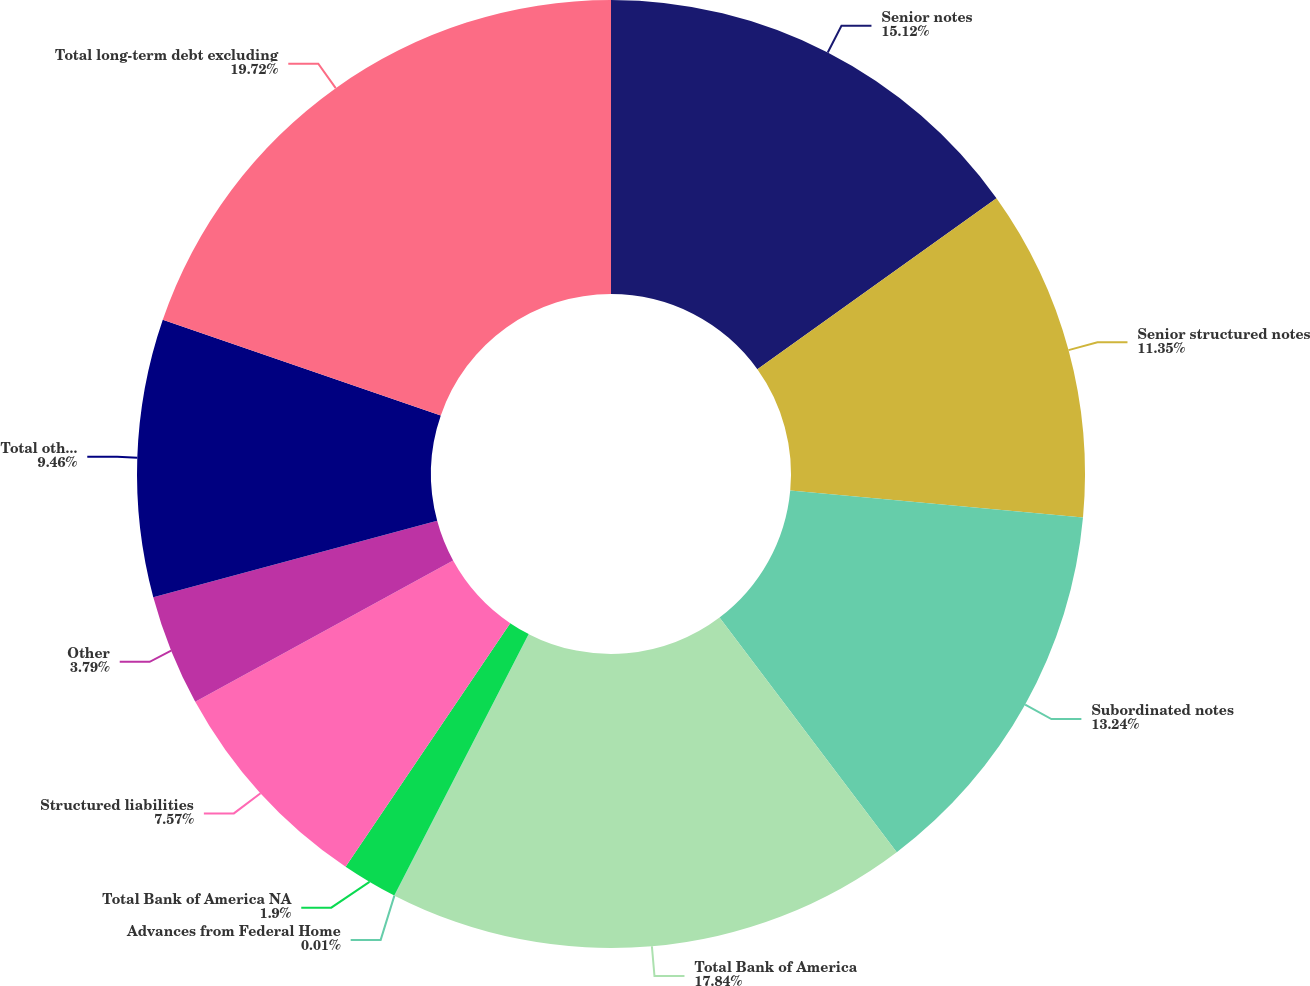Convert chart to OTSL. <chart><loc_0><loc_0><loc_500><loc_500><pie_chart><fcel>Senior notes<fcel>Senior structured notes<fcel>Subordinated notes<fcel>Total Bank of America<fcel>Advances from Federal Home<fcel>Total Bank of America NA<fcel>Structured liabilities<fcel>Other<fcel>Total other debt<fcel>Total long-term debt excluding<nl><fcel>15.12%<fcel>11.35%<fcel>13.24%<fcel>17.85%<fcel>0.01%<fcel>1.9%<fcel>7.57%<fcel>3.79%<fcel>9.46%<fcel>19.73%<nl></chart> 